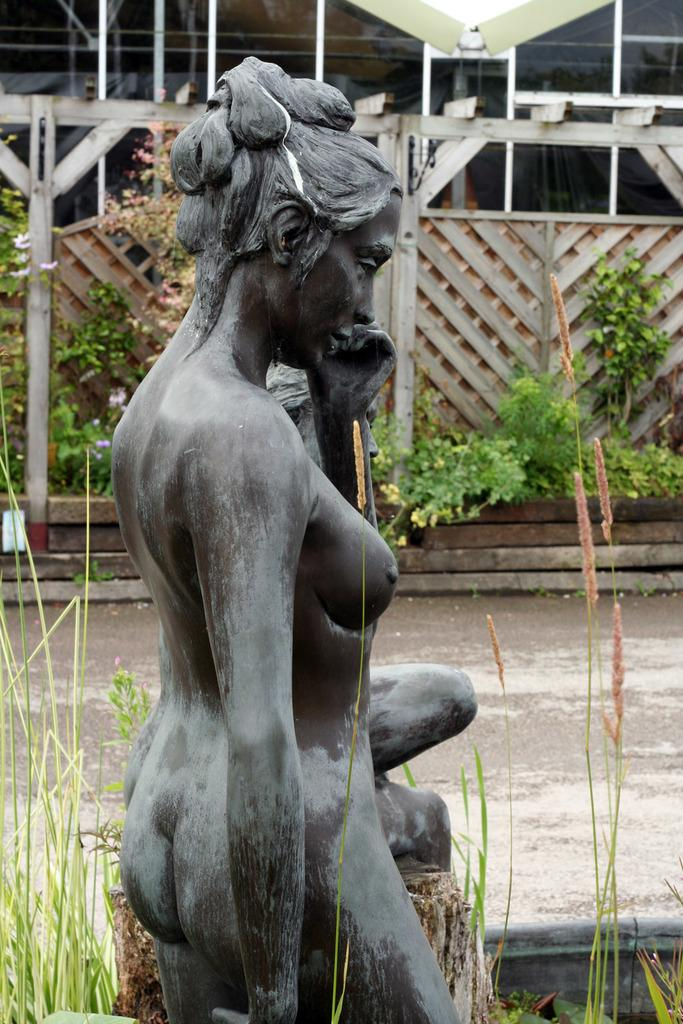What is the main subject of the image? There is a statue of a woman in the image. What else can be seen in the image besides the statue? There are plants and a wooden fence in the image. Where is the library located in the image? There is no library present in the image. Can you see any fish in the image? There are no fish present in the image. 